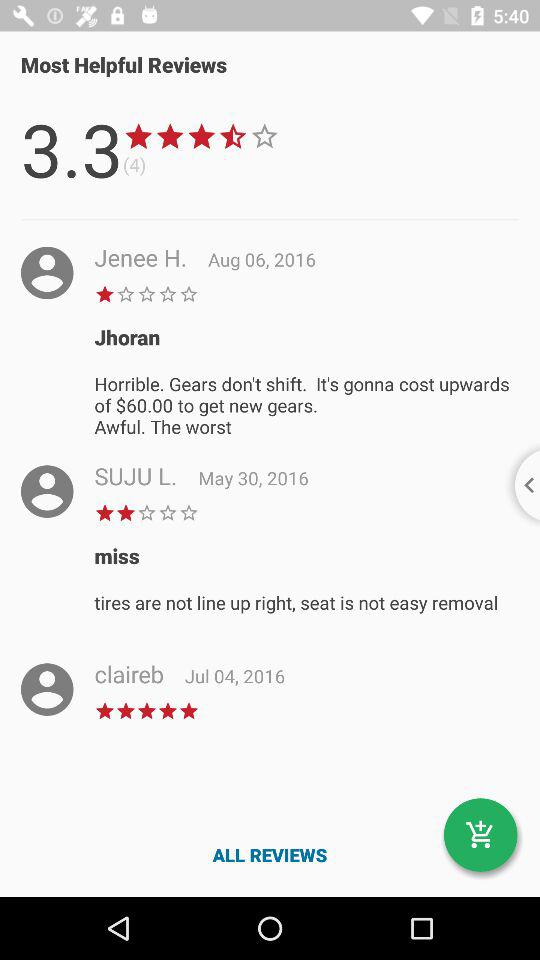What are the given reviews? The given reviews are "Jhoran", "Horrible. Gears don't shift. It's gonna cost upwards of $60.00 to get new gears. Awful. The worst", "miss" and "tires are not line up right, seat is not easy removal". 